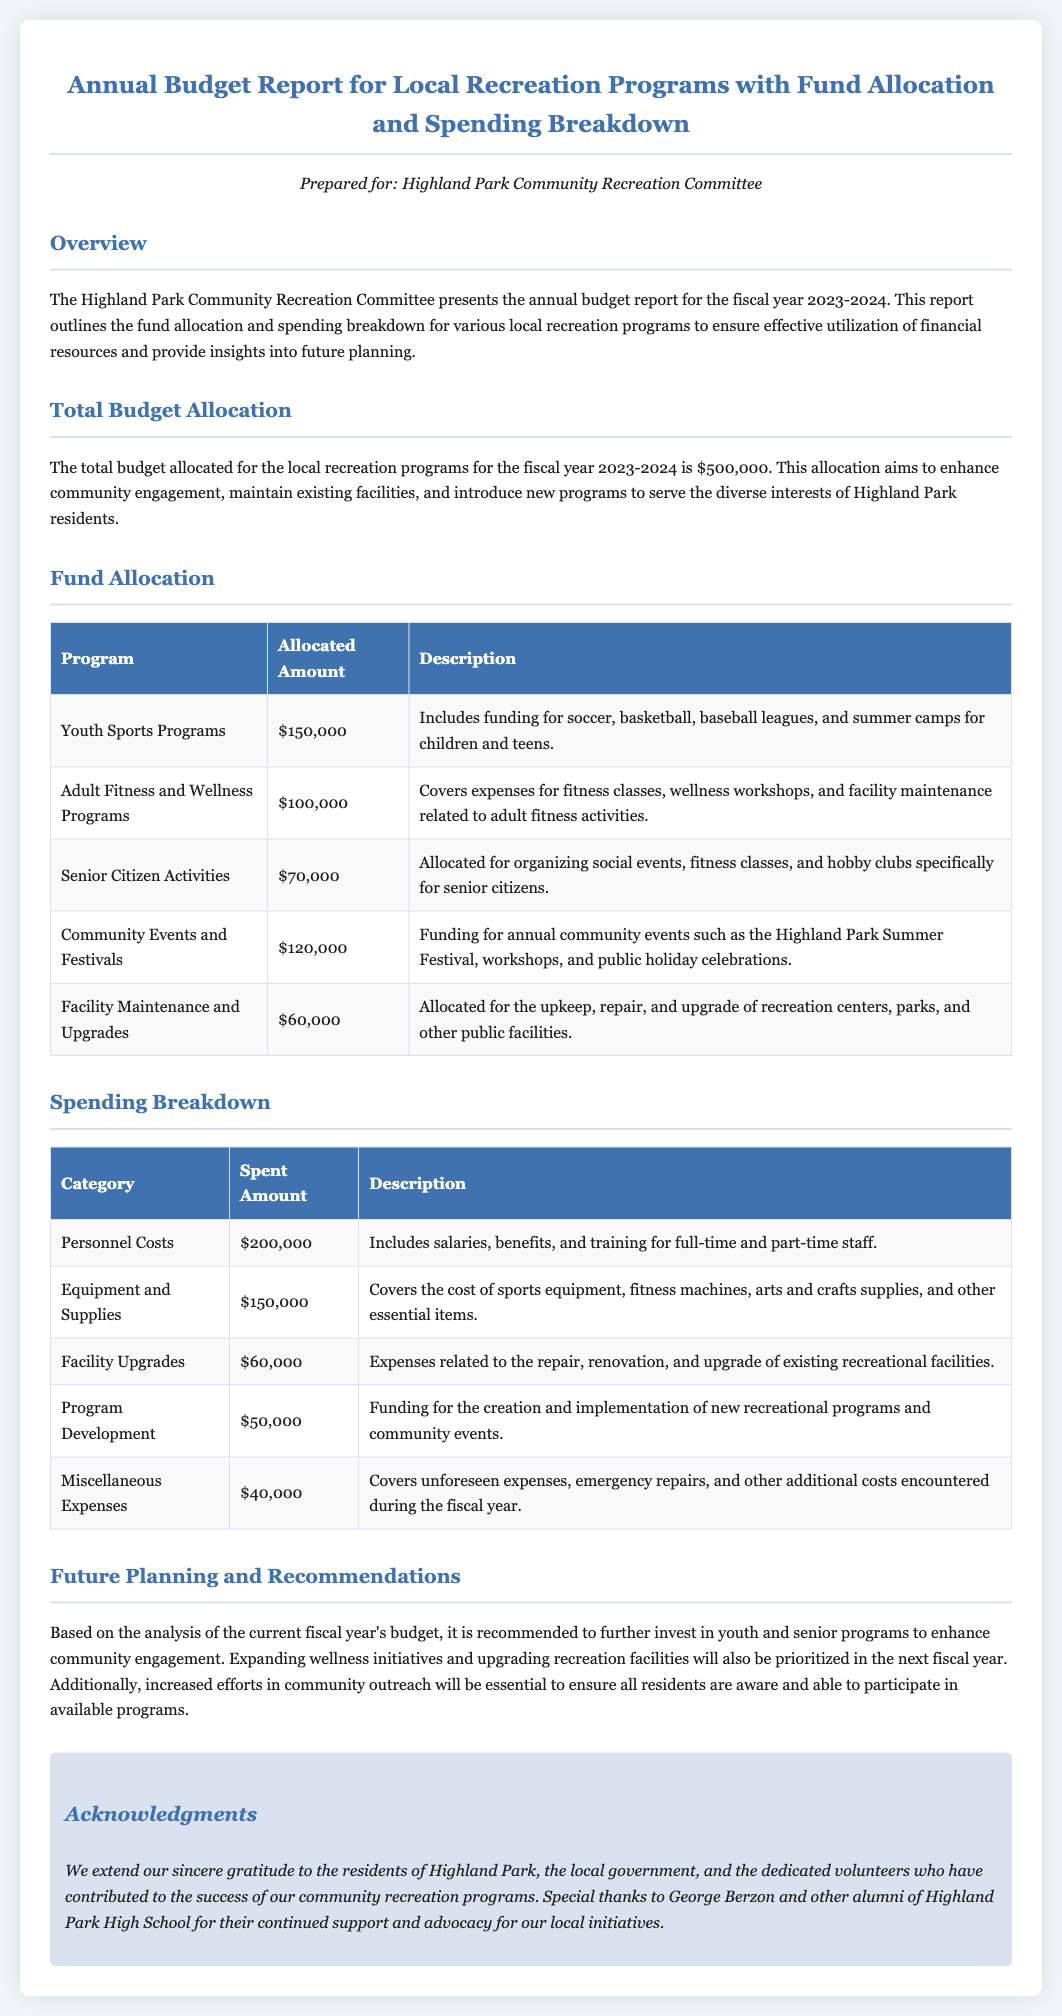What is the total budget allocated? The total budget allocated for local recreation programs is stated in the document as $500,000.
Answer: $500,000 How much is allocated for Youth Sports Programs? The allocated amount for Youth Sports Programs can be found in the fund allocation section of the document, which is $150,000.
Answer: $150,000 What percentage of the total budget is allocated to Community Events and Festivals? Community Events and Festivals are allocated $120,000 out of the total budget of $500,000, which can be calculated as (120000/500000)*100 = 24%.
Answer: 24% Which program has the highest allocation? The program with the highest allocation is Youth Sports Programs, according to the fund allocation table.
Answer: Youth Sports Programs What is the total spent on Personnel Costs? The spent amount on Personnel Costs is listed in the spending breakdown as $200,000.
Answer: $200,000 What is the allocated amount for Facility Maintenance and Upgrades? The allocated amount for Facility Maintenance and Upgrades is specified in the fund allocation section as $60,000.
Answer: $60,000 What category covers the least amount of spending? The category with the least amount of spending is Miscellaneous Expenses, according to the spending breakdown table.
Answer: Miscellaneous Expenses How much is spent on Program Development? The amount spent on Program Development is provided in the spending breakdown as $50,000.
Answer: $50,000 Who is acknowledged for their continued support? George Berzon is mentioned in the acknowledgments section for their continued support and advocacy.
Answer: George Berzon 